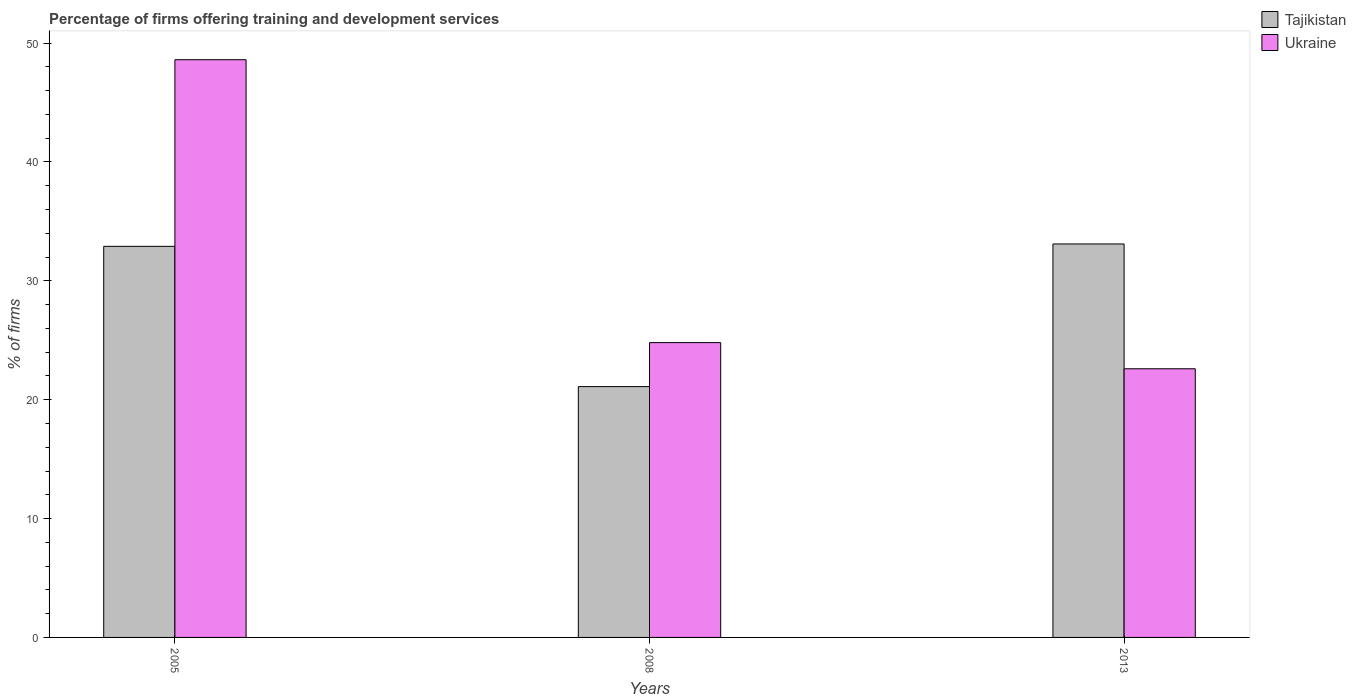How many different coloured bars are there?
Give a very brief answer. 2. Are the number of bars per tick equal to the number of legend labels?
Offer a terse response. Yes. How many bars are there on the 3rd tick from the right?
Ensure brevity in your answer.  2. In how many cases, is the number of bars for a given year not equal to the number of legend labels?
Provide a short and direct response. 0. What is the percentage of firms offering training and development in Ukraine in 2008?
Make the answer very short. 24.8. Across all years, what is the maximum percentage of firms offering training and development in Tajikistan?
Keep it short and to the point. 33.1. Across all years, what is the minimum percentage of firms offering training and development in Ukraine?
Provide a short and direct response. 22.6. In which year was the percentage of firms offering training and development in Tajikistan maximum?
Your answer should be very brief. 2013. What is the total percentage of firms offering training and development in Tajikistan in the graph?
Offer a very short reply. 87.1. What is the difference between the percentage of firms offering training and development in Tajikistan in 2005 and that in 2013?
Offer a terse response. -0.2. What is the difference between the percentage of firms offering training and development in Tajikistan in 2005 and the percentage of firms offering training and development in Ukraine in 2013?
Keep it short and to the point. 10.3. What is the average percentage of firms offering training and development in Ukraine per year?
Keep it short and to the point. 32. In the year 2005, what is the difference between the percentage of firms offering training and development in Ukraine and percentage of firms offering training and development in Tajikistan?
Ensure brevity in your answer.  15.7. What is the ratio of the percentage of firms offering training and development in Tajikistan in 2005 to that in 2013?
Offer a terse response. 0.99. Is the percentage of firms offering training and development in Ukraine in 2005 less than that in 2008?
Provide a succinct answer. No. Is the difference between the percentage of firms offering training and development in Ukraine in 2008 and 2013 greater than the difference between the percentage of firms offering training and development in Tajikistan in 2008 and 2013?
Ensure brevity in your answer.  Yes. What is the difference between the highest and the second highest percentage of firms offering training and development in Ukraine?
Provide a short and direct response. 23.8. What does the 2nd bar from the left in 2005 represents?
Provide a succinct answer. Ukraine. What does the 1st bar from the right in 2005 represents?
Your answer should be compact. Ukraine. What is the difference between two consecutive major ticks on the Y-axis?
Keep it short and to the point. 10. Where does the legend appear in the graph?
Your answer should be very brief. Top right. How many legend labels are there?
Provide a short and direct response. 2. How are the legend labels stacked?
Your answer should be very brief. Vertical. What is the title of the graph?
Offer a terse response. Percentage of firms offering training and development services. What is the label or title of the Y-axis?
Offer a very short reply. % of firms. What is the % of firms of Tajikistan in 2005?
Make the answer very short. 32.9. What is the % of firms in Ukraine in 2005?
Give a very brief answer. 48.6. What is the % of firms of Tajikistan in 2008?
Ensure brevity in your answer.  21.1. What is the % of firms of Ukraine in 2008?
Your answer should be very brief. 24.8. What is the % of firms of Tajikistan in 2013?
Make the answer very short. 33.1. What is the % of firms of Ukraine in 2013?
Give a very brief answer. 22.6. Across all years, what is the maximum % of firms of Tajikistan?
Give a very brief answer. 33.1. Across all years, what is the maximum % of firms in Ukraine?
Provide a short and direct response. 48.6. Across all years, what is the minimum % of firms in Tajikistan?
Your answer should be compact. 21.1. Across all years, what is the minimum % of firms of Ukraine?
Offer a very short reply. 22.6. What is the total % of firms of Tajikistan in the graph?
Your answer should be very brief. 87.1. What is the total % of firms in Ukraine in the graph?
Your answer should be very brief. 96. What is the difference between the % of firms of Ukraine in 2005 and that in 2008?
Offer a terse response. 23.8. What is the difference between the % of firms of Tajikistan in 2008 and that in 2013?
Your answer should be very brief. -12. What is the average % of firms in Tajikistan per year?
Keep it short and to the point. 29.03. What is the average % of firms of Ukraine per year?
Provide a short and direct response. 32. In the year 2005, what is the difference between the % of firms in Tajikistan and % of firms in Ukraine?
Provide a succinct answer. -15.7. In the year 2008, what is the difference between the % of firms in Tajikistan and % of firms in Ukraine?
Offer a very short reply. -3.7. In the year 2013, what is the difference between the % of firms of Tajikistan and % of firms of Ukraine?
Ensure brevity in your answer.  10.5. What is the ratio of the % of firms in Tajikistan in 2005 to that in 2008?
Ensure brevity in your answer.  1.56. What is the ratio of the % of firms in Ukraine in 2005 to that in 2008?
Make the answer very short. 1.96. What is the ratio of the % of firms of Ukraine in 2005 to that in 2013?
Your answer should be very brief. 2.15. What is the ratio of the % of firms in Tajikistan in 2008 to that in 2013?
Provide a short and direct response. 0.64. What is the ratio of the % of firms in Ukraine in 2008 to that in 2013?
Give a very brief answer. 1.1. What is the difference between the highest and the second highest % of firms in Ukraine?
Make the answer very short. 23.8. What is the difference between the highest and the lowest % of firms of Ukraine?
Provide a short and direct response. 26. 